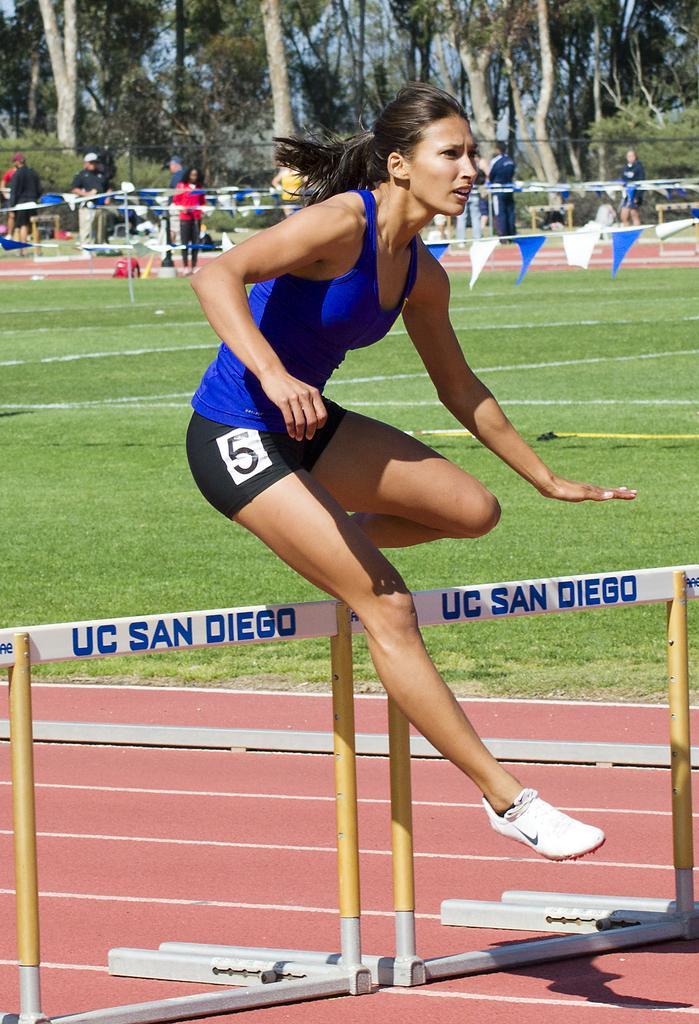Please provide a concise description of this image. In this image I can see a woman jumping in the center of the image. I can see a metal object in a stadium at the top of the image I can see trees and some people standing behind. 